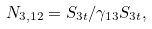<formula> <loc_0><loc_0><loc_500><loc_500>N _ { 3 , 1 2 } = S _ { 3 t } / \gamma _ { 1 3 } S _ { 3 t } ,</formula> 